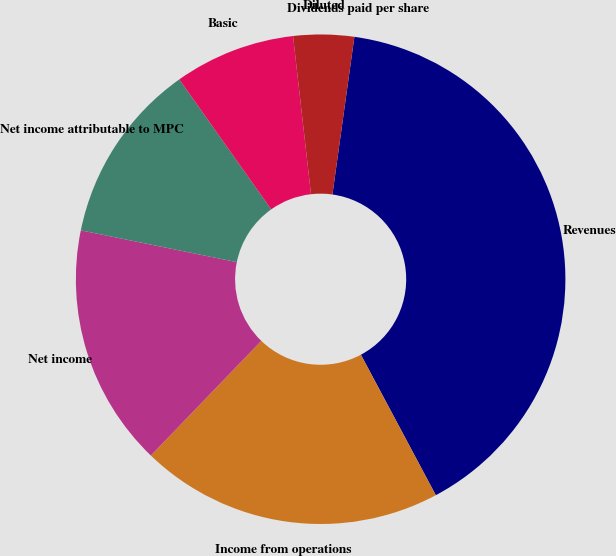Convert chart. <chart><loc_0><loc_0><loc_500><loc_500><pie_chart><fcel>Revenues<fcel>Income from operations<fcel>Net income<fcel>Net income attributable to MPC<fcel>Basic<fcel>Diluted<fcel>Dividends paid per share<nl><fcel>40.0%<fcel>20.0%<fcel>16.0%<fcel>12.0%<fcel>8.0%<fcel>4.0%<fcel>0.0%<nl></chart> 